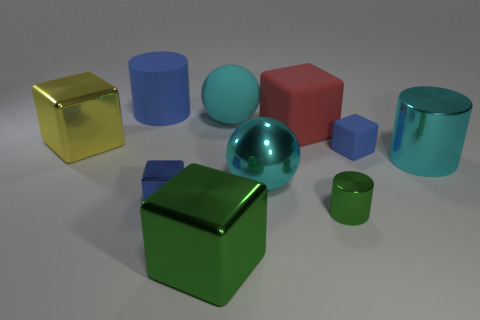What is the shape of the big yellow metal thing? The large yellow object in the image appears to be a cube due to its equal width, height, and depth, and its six square faces. The lighting reflects off its surface indicating it's metallic. 